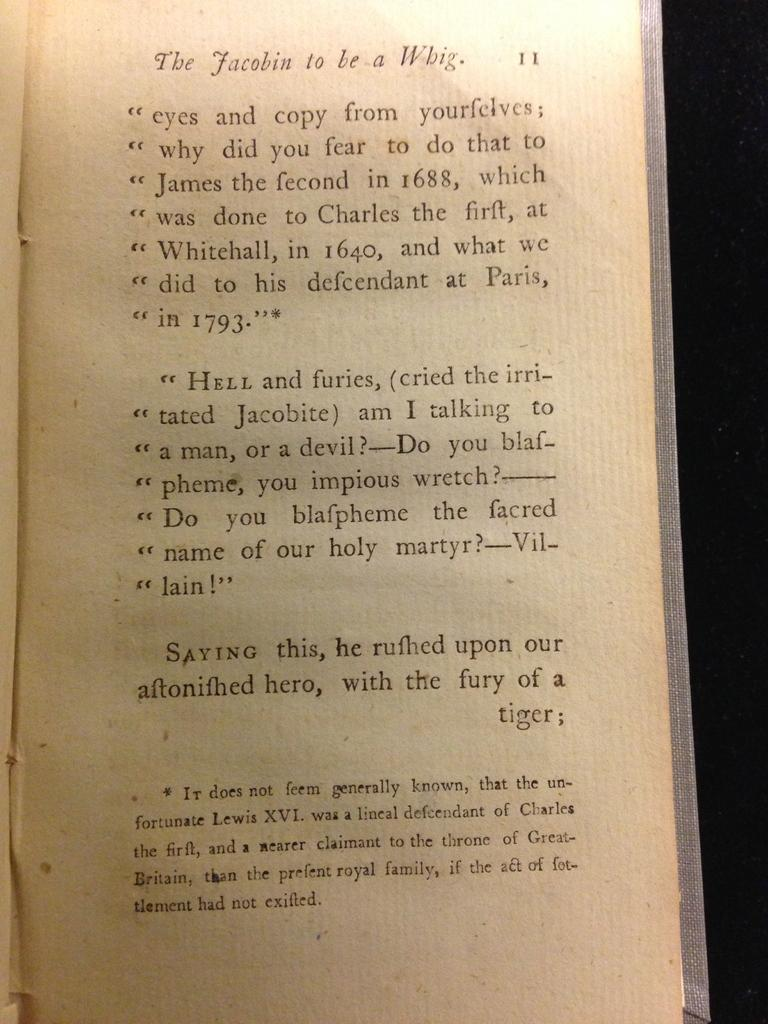<image>
Render a clear and concise summary of the photo. A book titles "The Jacobin to be a Whig." 